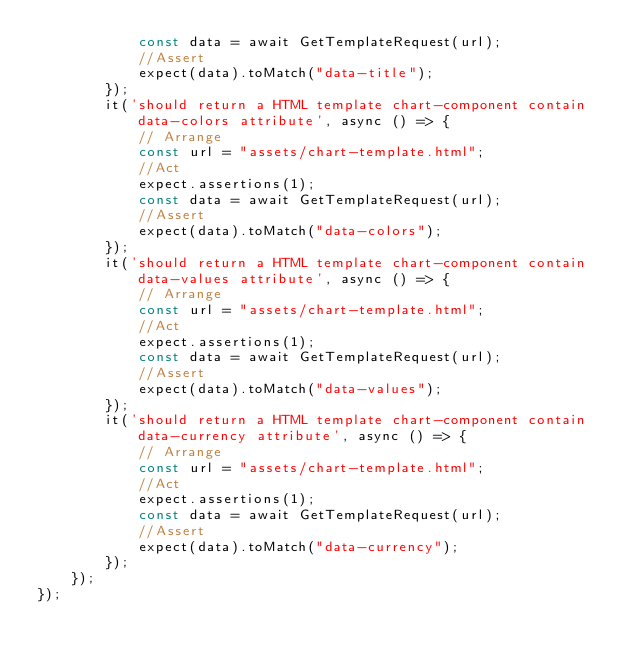<code> <loc_0><loc_0><loc_500><loc_500><_JavaScript_>            const data = await GetTemplateRequest(url);
            //Assert
            expect(data).toMatch("data-title");
        });
        it('should return a HTML template chart-component contain data-colors attribute', async () => {
            // Arrange
            const url = "assets/chart-template.html";
            //Act
            expect.assertions(1);
            const data = await GetTemplateRequest(url);
            //Assert
            expect(data).toMatch("data-colors");
        });
        it('should return a HTML template chart-component contain data-values attribute', async () => {
            // Arrange
            const url = "assets/chart-template.html";
            //Act
            expect.assertions(1);
            const data = await GetTemplateRequest(url);
            //Assert
            expect(data).toMatch("data-values");
        });
        it('should return a HTML template chart-component contain data-currency attribute', async () => {
            // Arrange
            const url = "assets/chart-template.html";
            //Act
            expect.assertions(1);
            const data = await GetTemplateRequest(url);
            //Assert
            expect(data).toMatch("data-currency");
        });
    });
});</code> 